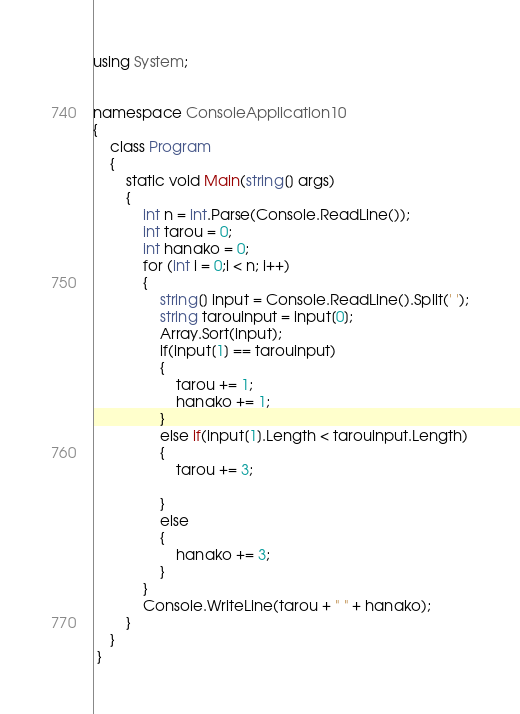Convert code to text. <code><loc_0><loc_0><loc_500><loc_500><_C#_>using System;


namespace ConsoleApplication10
{
    class Program
    {
        static void Main(string[] args)
        {
            int n = int.Parse(Console.ReadLine());
            int tarou = 0;
            int hanako = 0;
            for (int i = 0;i < n; i++)
            {
                string[] input = Console.ReadLine().Split(' ');
                string tarouinput = input[0];
                Array.Sort(input);
                if(input[1] == tarouinput)
                {
                    tarou += 1;
                    hanako += 1;
                }
                else if(input[1].Length < tarouinput.Length)
                {
                    tarou += 3;

                }
                else
                {
                    hanako += 3;
                }
            }
            Console.WriteLine(tarou + " " + hanako);
        }
    }
 }</code> 